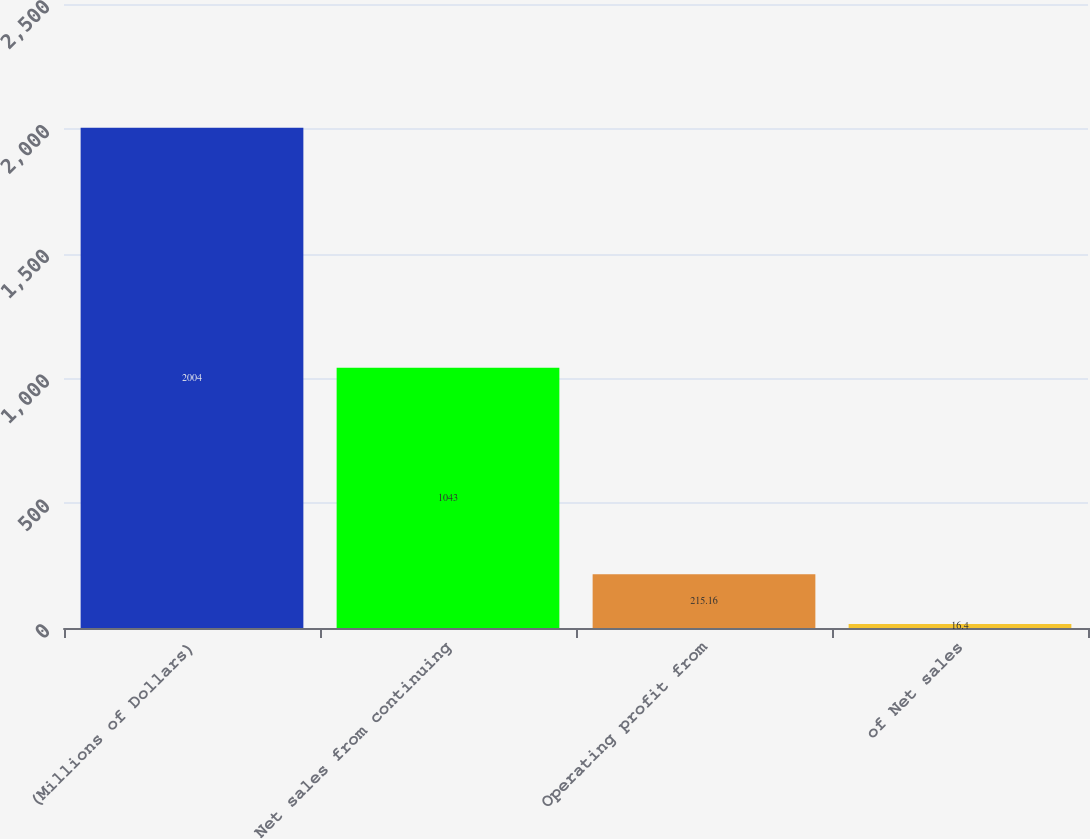Convert chart to OTSL. <chart><loc_0><loc_0><loc_500><loc_500><bar_chart><fcel>(Millions of Dollars)<fcel>Net sales from continuing<fcel>Operating profit from<fcel>of Net sales<nl><fcel>2004<fcel>1043<fcel>215.16<fcel>16.4<nl></chart> 